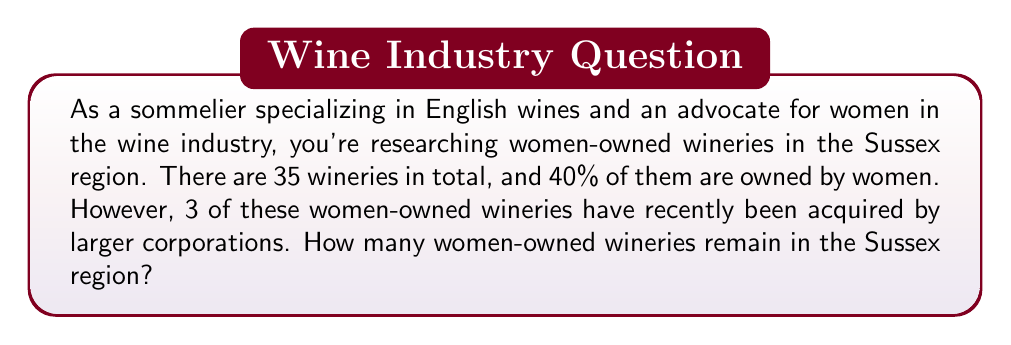Can you answer this question? Let's approach this problem step-by-step:

1. Calculate the initial number of women-owned wineries:
   $$ \text{Total wineries} \times \text{Percentage owned by women} = \text{Initial women-owned wineries} $$
   $$ 35 \times 0.40 = 14 $$

2. Subtract the number of wineries acquired by corporations:
   $$ \text{Initial women-owned wineries} - \text{Acquired wineries} = \text{Remaining women-owned wineries} $$
   $$ 14 - 3 = 11 $$

Therefore, 11 women-owned wineries remain in the Sussex region.

This calculation is particularly relevant for a sommelier advocating for women in the wine industry, as it provides insight into the current state of women's ownership in a specific English wine region.
Answer: 11 women-owned wineries 